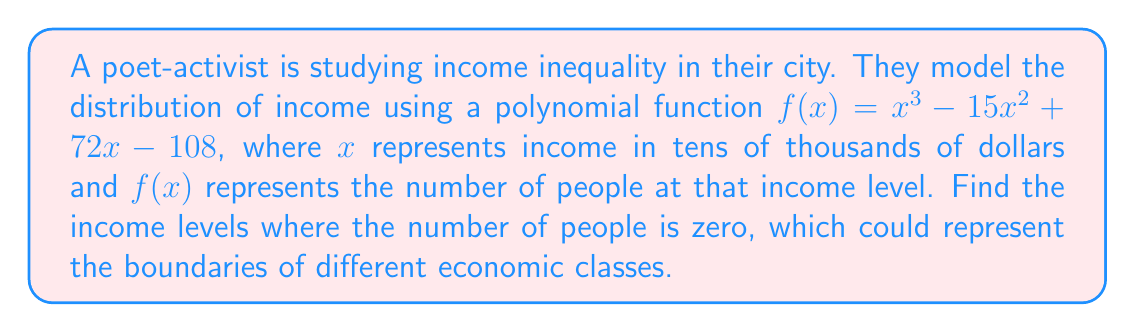Solve this math problem. To find the income levels where the number of people is zero, we need to find the roots of the polynomial equation:

$f(x) = x^3 - 15x^2 + 72x - 108 = 0$

1) First, let's check if there's a rational root using the rational root theorem. The possible rational roots are factors of 108: ±1, ±2, ±3, ±4, ±6, ±9, ±12, ±18, ±27, ±36, ±54, ±108.

2) Testing these, we find that 3 is a root. So $(x - 3)$ is a factor.

3) Divide the polynomial by $(x - 3)$:
   $x^3 - 15x^2 + 72x - 108 = (x - 3)(x^2 - 12x + 36)$

4) The quadratic factor $x^2 - 12x + 36$ can be solved using the quadratic formula:
   $x = \frac{-b \pm \sqrt{b^2 - 4ac}}{2a}$

   Where $a = 1$, $b = -12$, and $c = 36$

5) Substituting:
   $x = \frac{12 \pm \sqrt{144 - 144}}{2} = \frac{12 \pm 0}{2} = 6$

6) Therefore, the roots are 3 and 6 (with 6 being a double root).

These roots represent income levels of $30,000 and $60,000.
Answer: $30,000 and $60,000 